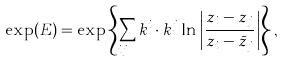<formula> <loc_0><loc_0><loc_500><loc_500>\exp ( E ) = \exp \left \{ \sum _ { i \neq j } k ^ { i } \cdot k ^ { j } \ln \left | \frac { z _ { i } - z _ { j } } { z _ { i } - \bar { z } _ { j } } \right | \right \} ,</formula> 